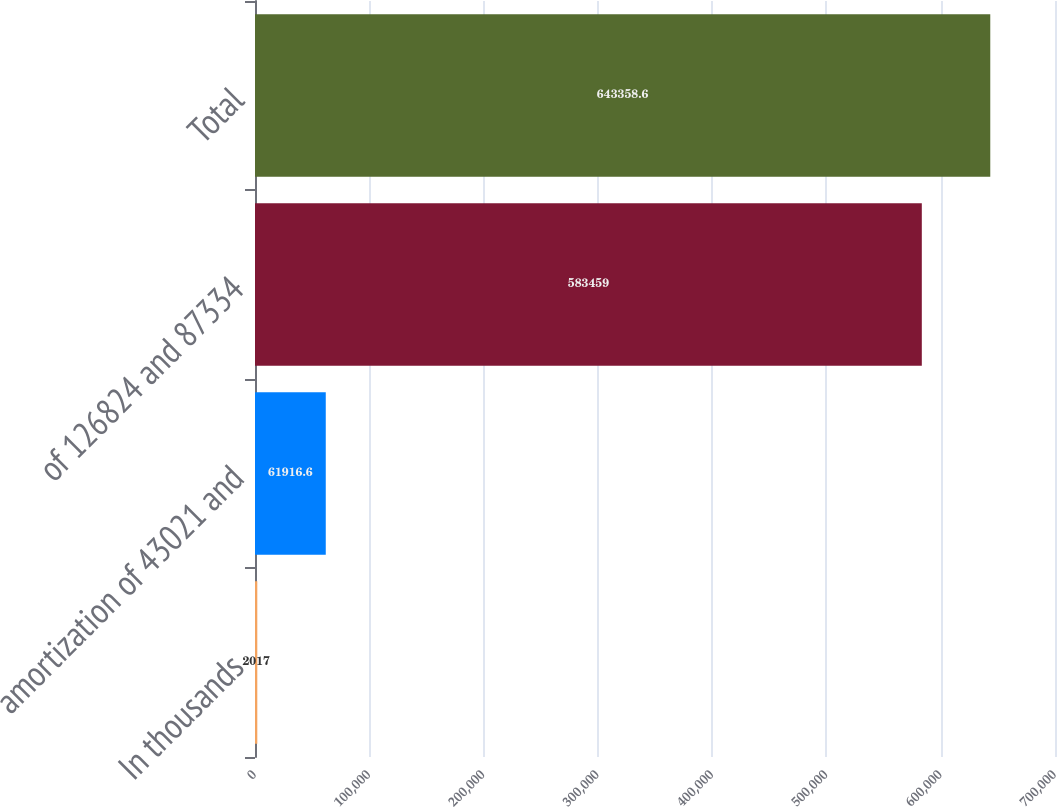<chart> <loc_0><loc_0><loc_500><loc_500><bar_chart><fcel>In thousands<fcel>amortization of 43021 and<fcel>of 126824 and 87334<fcel>Total<nl><fcel>2017<fcel>61916.6<fcel>583459<fcel>643359<nl></chart> 